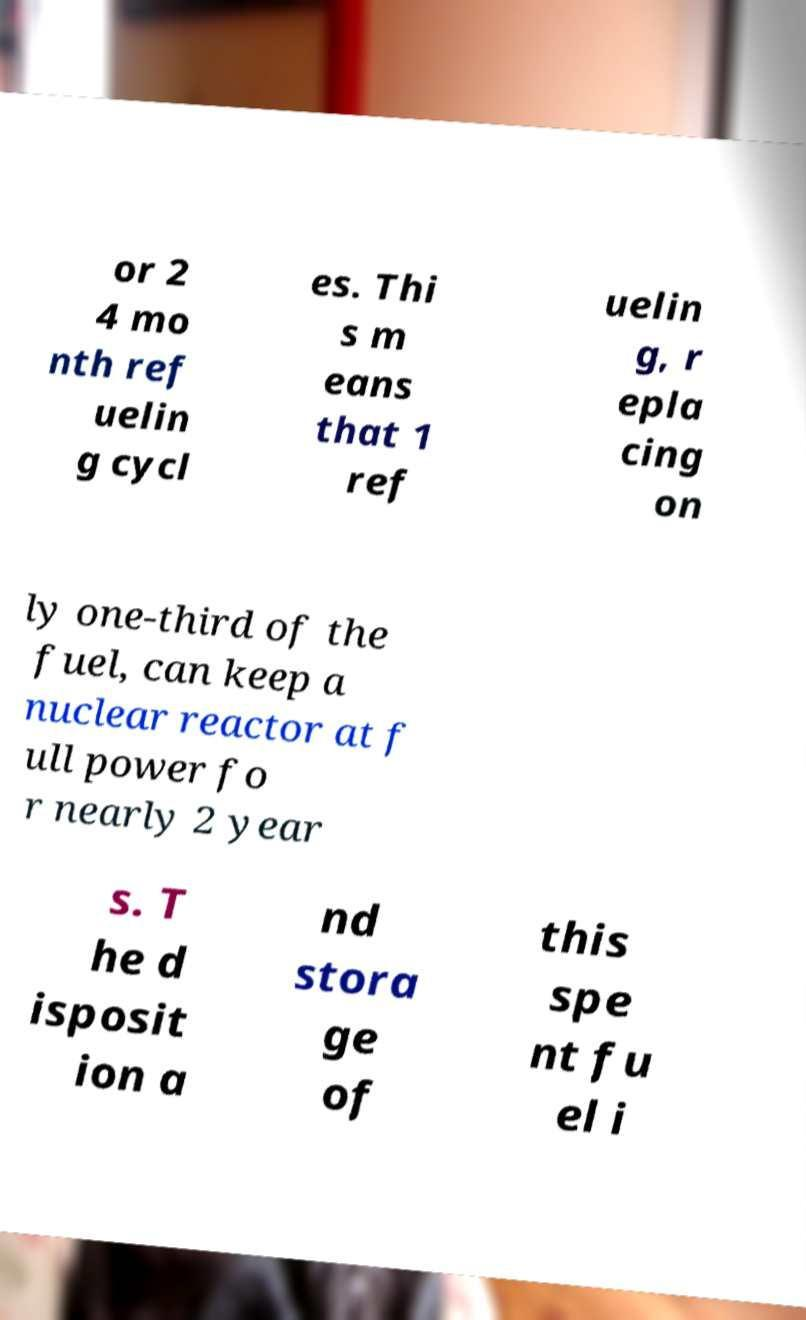I need the written content from this picture converted into text. Can you do that? or 2 4 mo nth ref uelin g cycl es. Thi s m eans that 1 ref uelin g, r epla cing on ly one-third of the fuel, can keep a nuclear reactor at f ull power fo r nearly 2 year s. T he d isposit ion a nd stora ge of this spe nt fu el i 